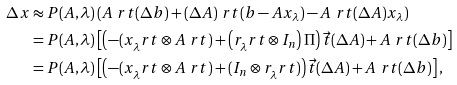Convert formula to latex. <formula><loc_0><loc_0><loc_500><loc_500>\Delta x & \approx P ( A , \lambda ) \left ( A ^ { \ } r t ( \Delta b ) + ( \Delta A ) ^ { \ } r t ( b - A x _ { \lambda } ) - A ^ { \ } r t ( \Delta A ) x _ { \lambda } \right ) \\ & = P ( A , \lambda ) \left [ \left ( - ( x _ { \lambda } ^ { \ } r t \otimes A ^ { \ } r t ) + \left ( r _ { \lambda } ^ { \ } r t \otimes I _ { n } \right ) \Pi \right ) \vec { t } ( \Delta A ) + A ^ { \ } r t ( \Delta b ) \right ] \\ & = P ( A , \lambda ) \left [ \left ( - ( x _ { \lambda } ^ { \ } r t \otimes A ^ { \ } r t ) + ( I _ { n } \otimes r _ { \lambda } ^ { \ } r t ) \right ) \vec { t } ( \Delta A ) + A ^ { \ } r t ( \Delta b ) \right ] ,</formula> 